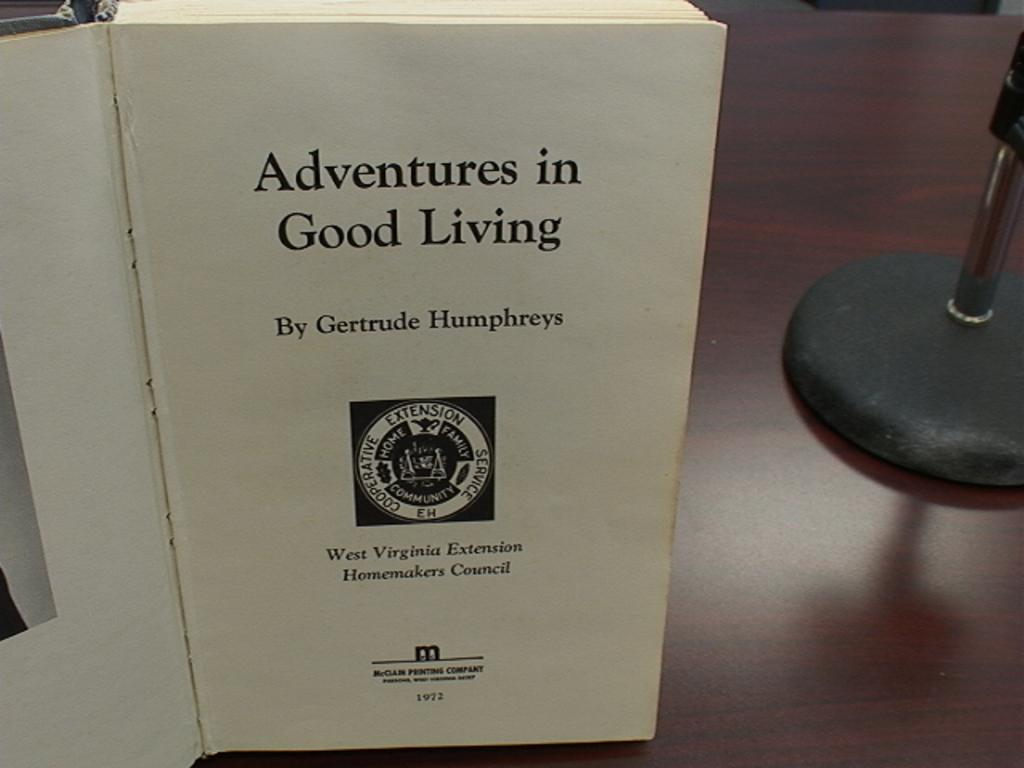<image>
Share a concise interpretation of the image provided. An open book with a page titled Adventures in Good Living. 